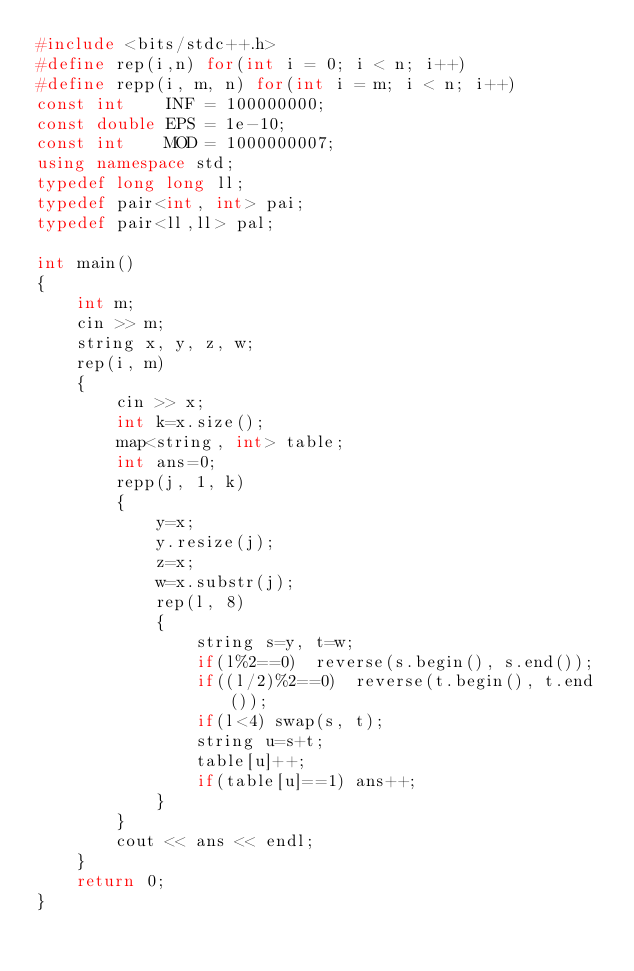<code> <loc_0><loc_0><loc_500><loc_500><_C++_>#include <bits/stdc++.h>
#define rep(i,n) for(int i = 0; i < n; i++)
#define repp(i, m, n) for(int i = m; i < n; i++)
const int    INF = 100000000;
const double EPS = 1e-10;
const int    MOD = 1000000007;
using namespace std;
typedef long long ll;
typedef pair<int, int> pai;
typedef pair<ll,ll> pal;

int main()
{
	int m;
	cin >> m;
	string x, y, z, w;
	rep(i, m)
	{
		cin >> x;
		int k=x.size();
		map<string, int> table;
		int ans=0;
		repp(j, 1, k)
		{
			y=x;
			y.resize(j);
			z=x;
			w=x.substr(j);
			rep(l, 8)
			{
				string s=y, t=w;
				if(l%2==0)	reverse(s.begin(), s.end());
				if((l/2)%2==0)	reverse(t.begin(), t.end());
				if(l<4) swap(s, t);
				string u=s+t;
				table[u]++;
				if(table[u]==1) ans++;
			}
		}
		cout << ans << endl;
	}
	return 0;
}</code> 